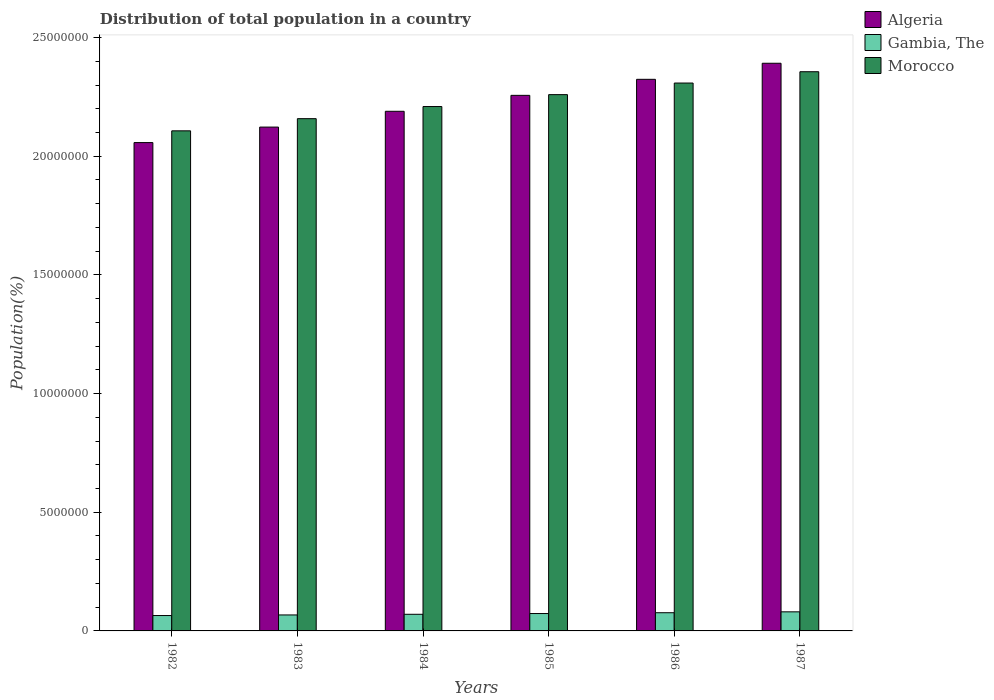How many bars are there on the 1st tick from the right?
Offer a terse response. 3. What is the label of the 6th group of bars from the left?
Your answer should be very brief. 1987. In how many cases, is the number of bars for a given year not equal to the number of legend labels?
Offer a terse response. 0. What is the population of in Gambia, The in 1982?
Keep it short and to the point. 6.48e+05. Across all years, what is the maximum population of in Algeria?
Your answer should be very brief. 2.39e+07. Across all years, what is the minimum population of in Gambia, The?
Keep it short and to the point. 6.48e+05. In which year was the population of in Gambia, The minimum?
Keep it short and to the point. 1982. What is the total population of in Gambia, The in the graph?
Your answer should be very brief. 4.33e+06. What is the difference between the population of in Morocco in 1983 and that in 1987?
Your answer should be very brief. -1.98e+06. What is the difference between the population of in Gambia, The in 1987 and the population of in Morocco in 1983?
Your answer should be very brief. -2.08e+07. What is the average population of in Morocco per year?
Your answer should be very brief. 2.23e+07. In the year 1986, what is the difference between the population of in Gambia, The and population of in Algeria?
Ensure brevity in your answer.  -2.25e+07. In how many years, is the population of in Algeria greater than 18000000 %?
Your response must be concise. 6. What is the ratio of the population of in Morocco in 1982 to that in 1984?
Provide a short and direct response. 0.95. What is the difference between the highest and the second highest population of in Morocco?
Ensure brevity in your answer.  4.76e+05. What is the difference between the highest and the lowest population of in Gambia, The?
Make the answer very short. 1.56e+05. What does the 2nd bar from the left in 1985 represents?
Ensure brevity in your answer.  Gambia, The. What does the 2nd bar from the right in 1985 represents?
Your response must be concise. Gambia, The. Is it the case that in every year, the sum of the population of in Gambia, The and population of in Morocco is greater than the population of in Algeria?
Give a very brief answer. Yes. What is the difference between two consecutive major ticks on the Y-axis?
Provide a short and direct response. 5.00e+06. Are the values on the major ticks of Y-axis written in scientific E-notation?
Make the answer very short. No. Does the graph contain any zero values?
Your answer should be compact. No. How many legend labels are there?
Ensure brevity in your answer.  3. What is the title of the graph?
Ensure brevity in your answer.  Distribution of total population in a country. What is the label or title of the Y-axis?
Ensure brevity in your answer.  Population(%). What is the Population(%) in Algeria in 1982?
Keep it short and to the point. 2.06e+07. What is the Population(%) in Gambia, The in 1982?
Offer a very short reply. 6.48e+05. What is the Population(%) in Morocco in 1982?
Your answer should be compact. 2.11e+07. What is the Population(%) of Algeria in 1983?
Provide a short and direct response. 2.12e+07. What is the Population(%) in Gambia, The in 1983?
Provide a short and direct response. 6.73e+05. What is the Population(%) of Morocco in 1983?
Provide a succinct answer. 2.16e+07. What is the Population(%) in Algeria in 1984?
Offer a very short reply. 2.19e+07. What is the Population(%) in Gambia, The in 1984?
Ensure brevity in your answer.  7.01e+05. What is the Population(%) in Morocco in 1984?
Ensure brevity in your answer.  2.21e+07. What is the Population(%) in Algeria in 1985?
Make the answer very short. 2.26e+07. What is the Population(%) of Gambia, The in 1985?
Give a very brief answer. 7.32e+05. What is the Population(%) of Morocco in 1985?
Provide a succinct answer. 2.26e+07. What is the Population(%) of Algeria in 1986?
Provide a succinct answer. 2.32e+07. What is the Population(%) in Gambia, The in 1986?
Provide a short and direct response. 7.67e+05. What is the Population(%) of Morocco in 1986?
Give a very brief answer. 2.31e+07. What is the Population(%) of Algeria in 1987?
Provide a succinct answer. 2.39e+07. What is the Population(%) in Gambia, The in 1987?
Offer a terse response. 8.04e+05. What is the Population(%) in Morocco in 1987?
Give a very brief answer. 2.36e+07. Across all years, what is the maximum Population(%) of Algeria?
Your answer should be very brief. 2.39e+07. Across all years, what is the maximum Population(%) in Gambia, The?
Provide a short and direct response. 8.04e+05. Across all years, what is the maximum Population(%) in Morocco?
Your answer should be very brief. 2.36e+07. Across all years, what is the minimum Population(%) in Algeria?
Offer a terse response. 2.06e+07. Across all years, what is the minimum Population(%) of Gambia, The?
Make the answer very short. 6.48e+05. Across all years, what is the minimum Population(%) of Morocco?
Offer a very short reply. 2.11e+07. What is the total Population(%) of Algeria in the graph?
Provide a short and direct response. 1.33e+08. What is the total Population(%) in Gambia, The in the graph?
Provide a succinct answer. 4.33e+06. What is the total Population(%) of Morocco in the graph?
Offer a terse response. 1.34e+08. What is the difference between the Population(%) in Algeria in 1982 and that in 1983?
Give a very brief answer. -6.53e+05. What is the difference between the Population(%) in Gambia, The in 1982 and that in 1983?
Make the answer very short. -2.50e+04. What is the difference between the Population(%) of Morocco in 1982 and that in 1983?
Provide a succinct answer. -5.13e+05. What is the difference between the Population(%) in Algeria in 1982 and that in 1984?
Provide a succinct answer. -1.32e+06. What is the difference between the Population(%) in Gambia, The in 1982 and that in 1984?
Provide a short and direct response. -5.29e+04. What is the difference between the Population(%) of Morocco in 1982 and that in 1984?
Offer a very short reply. -1.02e+06. What is the difference between the Population(%) in Algeria in 1982 and that in 1985?
Make the answer very short. -1.99e+06. What is the difference between the Population(%) in Gambia, The in 1982 and that in 1985?
Your answer should be compact. -8.39e+04. What is the difference between the Population(%) in Morocco in 1982 and that in 1985?
Provide a succinct answer. -1.53e+06. What is the difference between the Population(%) of Algeria in 1982 and that in 1986?
Your answer should be very brief. -2.67e+06. What is the difference between the Population(%) in Gambia, The in 1982 and that in 1986?
Provide a short and direct response. -1.18e+05. What is the difference between the Population(%) of Morocco in 1982 and that in 1986?
Offer a terse response. -2.01e+06. What is the difference between the Population(%) of Algeria in 1982 and that in 1987?
Give a very brief answer. -3.34e+06. What is the difference between the Population(%) of Gambia, The in 1982 and that in 1987?
Your response must be concise. -1.56e+05. What is the difference between the Population(%) of Morocco in 1982 and that in 1987?
Your answer should be compact. -2.49e+06. What is the difference between the Population(%) in Algeria in 1983 and that in 1984?
Keep it short and to the point. -6.66e+05. What is the difference between the Population(%) of Gambia, The in 1983 and that in 1984?
Offer a terse response. -2.79e+04. What is the difference between the Population(%) of Morocco in 1983 and that in 1984?
Provide a short and direct response. -5.11e+05. What is the difference between the Population(%) in Algeria in 1983 and that in 1985?
Make the answer very short. -1.34e+06. What is the difference between the Population(%) of Gambia, The in 1983 and that in 1985?
Offer a very short reply. -5.89e+04. What is the difference between the Population(%) of Morocco in 1983 and that in 1985?
Ensure brevity in your answer.  -1.01e+06. What is the difference between the Population(%) in Algeria in 1983 and that in 1986?
Make the answer very short. -2.01e+06. What is the difference between the Population(%) of Gambia, The in 1983 and that in 1986?
Make the answer very short. -9.34e+04. What is the difference between the Population(%) of Morocco in 1983 and that in 1986?
Give a very brief answer. -1.50e+06. What is the difference between the Population(%) in Algeria in 1983 and that in 1987?
Offer a very short reply. -2.69e+06. What is the difference between the Population(%) in Gambia, The in 1983 and that in 1987?
Your answer should be very brief. -1.31e+05. What is the difference between the Population(%) in Morocco in 1983 and that in 1987?
Your response must be concise. -1.98e+06. What is the difference between the Population(%) in Algeria in 1984 and that in 1985?
Your answer should be very brief. -6.72e+05. What is the difference between the Population(%) in Gambia, The in 1984 and that in 1985?
Your answer should be very brief. -3.10e+04. What is the difference between the Population(%) of Morocco in 1984 and that in 1985?
Your answer should be very brief. -5.02e+05. What is the difference between the Population(%) of Algeria in 1984 and that in 1986?
Your response must be concise. -1.35e+06. What is the difference between the Population(%) in Gambia, The in 1984 and that in 1986?
Provide a succinct answer. -6.55e+04. What is the difference between the Population(%) in Morocco in 1984 and that in 1986?
Your answer should be compact. -9.90e+05. What is the difference between the Population(%) in Algeria in 1984 and that in 1987?
Give a very brief answer. -2.02e+06. What is the difference between the Population(%) in Gambia, The in 1984 and that in 1987?
Ensure brevity in your answer.  -1.03e+05. What is the difference between the Population(%) of Morocco in 1984 and that in 1987?
Keep it short and to the point. -1.47e+06. What is the difference between the Population(%) of Algeria in 1985 and that in 1986?
Offer a terse response. -6.75e+05. What is the difference between the Population(%) in Gambia, The in 1985 and that in 1986?
Give a very brief answer. -3.45e+04. What is the difference between the Population(%) of Morocco in 1985 and that in 1986?
Your answer should be very brief. -4.89e+05. What is the difference between the Population(%) of Algeria in 1985 and that in 1987?
Your response must be concise. -1.35e+06. What is the difference between the Population(%) in Gambia, The in 1985 and that in 1987?
Give a very brief answer. -7.20e+04. What is the difference between the Population(%) in Morocco in 1985 and that in 1987?
Give a very brief answer. -9.65e+05. What is the difference between the Population(%) of Algeria in 1986 and that in 1987?
Your response must be concise. -6.77e+05. What is the difference between the Population(%) in Gambia, The in 1986 and that in 1987?
Ensure brevity in your answer.  -3.75e+04. What is the difference between the Population(%) of Morocco in 1986 and that in 1987?
Provide a short and direct response. -4.76e+05. What is the difference between the Population(%) in Algeria in 1982 and the Population(%) in Gambia, The in 1983?
Keep it short and to the point. 1.99e+07. What is the difference between the Population(%) in Algeria in 1982 and the Population(%) in Morocco in 1983?
Keep it short and to the point. -1.01e+06. What is the difference between the Population(%) of Gambia, The in 1982 and the Population(%) of Morocco in 1983?
Offer a terse response. -2.09e+07. What is the difference between the Population(%) of Algeria in 1982 and the Population(%) of Gambia, The in 1984?
Provide a succinct answer. 1.99e+07. What is the difference between the Population(%) in Algeria in 1982 and the Population(%) in Morocco in 1984?
Make the answer very short. -1.52e+06. What is the difference between the Population(%) of Gambia, The in 1982 and the Population(%) of Morocco in 1984?
Offer a very short reply. -2.14e+07. What is the difference between the Population(%) of Algeria in 1982 and the Population(%) of Gambia, The in 1985?
Make the answer very short. 1.98e+07. What is the difference between the Population(%) in Algeria in 1982 and the Population(%) in Morocco in 1985?
Your answer should be compact. -2.02e+06. What is the difference between the Population(%) of Gambia, The in 1982 and the Population(%) of Morocco in 1985?
Offer a terse response. -2.19e+07. What is the difference between the Population(%) in Algeria in 1982 and the Population(%) in Gambia, The in 1986?
Offer a terse response. 1.98e+07. What is the difference between the Population(%) in Algeria in 1982 and the Population(%) in Morocco in 1986?
Make the answer very short. -2.51e+06. What is the difference between the Population(%) in Gambia, The in 1982 and the Population(%) in Morocco in 1986?
Ensure brevity in your answer.  -2.24e+07. What is the difference between the Population(%) in Algeria in 1982 and the Population(%) in Gambia, The in 1987?
Your answer should be very brief. 1.98e+07. What is the difference between the Population(%) in Algeria in 1982 and the Population(%) in Morocco in 1987?
Your response must be concise. -2.99e+06. What is the difference between the Population(%) of Gambia, The in 1982 and the Population(%) of Morocco in 1987?
Make the answer very short. -2.29e+07. What is the difference between the Population(%) of Algeria in 1983 and the Population(%) of Gambia, The in 1984?
Your answer should be very brief. 2.05e+07. What is the difference between the Population(%) in Algeria in 1983 and the Population(%) in Morocco in 1984?
Provide a succinct answer. -8.66e+05. What is the difference between the Population(%) of Gambia, The in 1983 and the Population(%) of Morocco in 1984?
Offer a terse response. -2.14e+07. What is the difference between the Population(%) of Algeria in 1983 and the Population(%) of Gambia, The in 1985?
Offer a very short reply. 2.05e+07. What is the difference between the Population(%) in Algeria in 1983 and the Population(%) in Morocco in 1985?
Provide a short and direct response. -1.37e+06. What is the difference between the Population(%) of Gambia, The in 1983 and the Population(%) of Morocco in 1985?
Offer a terse response. -2.19e+07. What is the difference between the Population(%) of Algeria in 1983 and the Population(%) of Gambia, The in 1986?
Give a very brief answer. 2.05e+07. What is the difference between the Population(%) in Algeria in 1983 and the Population(%) in Morocco in 1986?
Give a very brief answer. -1.86e+06. What is the difference between the Population(%) of Gambia, The in 1983 and the Population(%) of Morocco in 1986?
Provide a succinct answer. -2.24e+07. What is the difference between the Population(%) in Algeria in 1983 and the Population(%) in Gambia, The in 1987?
Your answer should be compact. 2.04e+07. What is the difference between the Population(%) of Algeria in 1983 and the Population(%) of Morocco in 1987?
Provide a short and direct response. -2.33e+06. What is the difference between the Population(%) in Gambia, The in 1983 and the Population(%) in Morocco in 1987?
Offer a very short reply. -2.29e+07. What is the difference between the Population(%) in Algeria in 1984 and the Population(%) in Gambia, The in 1985?
Give a very brief answer. 2.12e+07. What is the difference between the Population(%) of Algeria in 1984 and the Population(%) of Morocco in 1985?
Your answer should be compact. -7.02e+05. What is the difference between the Population(%) of Gambia, The in 1984 and the Population(%) of Morocco in 1985?
Your answer should be compact. -2.19e+07. What is the difference between the Population(%) in Algeria in 1984 and the Population(%) in Gambia, The in 1986?
Make the answer very short. 2.11e+07. What is the difference between the Population(%) in Algeria in 1984 and the Population(%) in Morocco in 1986?
Your answer should be compact. -1.19e+06. What is the difference between the Population(%) of Gambia, The in 1984 and the Population(%) of Morocco in 1986?
Your answer should be compact. -2.24e+07. What is the difference between the Population(%) in Algeria in 1984 and the Population(%) in Gambia, The in 1987?
Give a very brief answer. 2.11e+07. What is the difference between the Population(%) of Algeria in 1984 and the Population(%) of Morocco in 1987?
Your response must be concise. -1.67e+06. What is the difference between the Population(%) of Gambia, The in 1984 and the Population(%) of Morocco in 1987?
Provide a short and direct response. -2.29e+07. What is the difference between the Population(%) of Algeria in 1985 and the Population(%) of Gambia, The in 1986?
Your response must be concise. 2.18e+07. What is the difference between the Population(%) of Algeria in 1985 and the Population(%) of Morocco in 1986?
Provide a short and direct response. -5.19e+05. What is the difference between the Population(%) of Gambia, The in 1985 and the Population(%) of Morocco in 1986?
Provide a succinct answer. -2.24e+07. What is the difference between the Population(%) of Algeria in 1985 and the Population(%) of Gambia, The in 1987?
Make the answer very short. 2.18e+07. What is the difference between the Population(%) in Algeria in 1985 and the Population(%) in Morocco in 1987?
Make the answer very short. -9.95e+05. What is the difference between the Population(%) in Gambia, The in 1985 and the Population(%) in Morocco in 1987?
Offer a terse response. -2.28e+07. What is the difference between the Population(%) of Algeria in 1986 and the Population(%) of Gambia, The in 1987?
Offer a terse response. 2.24e+07. What is the difference between the Population(%) in Algeria in 1986 and the Population(%) in Morocco in 1987?
Make the answer very short. -3.20e+05. What is the difference between the Population(%) of Gambia, The in 1986 and the Population(%) of Morocco in 1987?
Keep it short and to the point. -2.28e+07. What is the average Population(%) in Algeria per year?
Offer a terse response. 2.22e+07. What is the average Population(%) of Gambia, The per year?
Keep it short and to the point. 7.21e+05. What is the average Population(%) of Morocco per year?
Keep it short and to the point. 2.23e+07. In the year 1982, what is the difference between the Population(%) in Algeria and Population(%) in Gambia, The?
Give a very brief answer. 1.99e+07. In the year 1982, what is the difference between the Population(%) of Algeria and Population(%) of Morocco?
Ensure brevity in your answer.  -4.95e+05. In the year 1982, what is the difference between the Population(%) in Gambia, The and Population(%) in Morocco?
Keep it short and to the point. -2.04e+07. In the year 1983, what is the difference between the Population(%) of Algeria and Population(%) of Gambia, The?
Offer a very short reply. 2.06e+07. In the year 1983, what is the difference between the Population(%) in Algeria and Population(%) in Morocco?
Make the answer very short. -3.55e+05. In the year 1983, what is the difference between the Population(%) in Gambia, The and Population(%) in Morocco?
Make the answer very short. -2.09e+07. In the year 1984, what is the difference between the Population(%) in Algeria and Population(%) in Gambia, The?
Ensure brevity in your answer.  2.12e+07. In the year 1984, what is the difference between the Population(%) in Algeria and Population(%) in Morocco?
Provide a short and direct response. -2.01e+05. In the year 1984, what is the difference between the Population(%) in Gambia, The and Population(%) in Morocco?
Keep it short and to the point. -2.14e+07. In the year 1985, what is the difference between the Population(%) in Algeria and Population(%) in Gambia, The?
Offer a very short reply. 2.18e+07. In the year 1985, what is the difference between the Population(%) of Algeria and Population(%) of Morocco?
Give a very brief answer. -3.02e+04. In the year 1985, what is the difference between the Population(%) in Gambia, The and Population(%) in Morocco?
Your answer should be compact. -2.19e+07. In the year 1986, what is the difference between the Population(%) in Algeria and Population(%) in Gambia, The?
Ensure brevity in your answer.  2.25e+07. In the year 1986, what is the difference between the Population(%) in Algeria and Population(%) in Morocco?
Keep it short and to the point. 1.57e+05. In the year 1986, what is the difference between the Population(%) in Gambia, The and Population(%) in Morocco?
Provide a succinct answer. -2.23e+07. In the year 1987, what is the difference between the Population(%) of Algeria and Population(%) of Gambia, The?
Give a very brief answer. 2.31e+07. In the year 1987, what is the difference between the Population(%) of Algeria and Population(%) of Morocco?
Keep it short and to the point. 3.57e+05. In the year 1987, what is the difference between the Population(%) of Gambia, The and Population(%) of Morocco?
Provide a short and direct response. -2.28e+07. What is the ratio of the Population(%) of Algeria in 1982 to that in 1983?
Make the answer very short. 0.97. What is the ratio of the Population(%) of Gambia, The in 1982 to that in 1983?
Offer a terse response. 0.96. What is the ratio of the Population(%) in Morocco in 1982 to that in 1983?
Keep it short and to the point. 0.98. What is the ratio of the Population(%) of Algeria in 1982 to that in 1984?
Your answer should be compact. 0.94. What is the ratio of the Population(%) of Gambia, The in 1982 to that in 1984?
Provide a short and direct response. 0.92. What is the ratio of the Population(%) of Morocco in 1982 to that in 1984?
Offer a very short reply. 0.95. What is the ratio of the Population(%) in Algeria in 1982 to that in 1985?
Your answer should be very brief. 0.91. What is the ratio of the Population(%) of Gambia, The in 1982 to that in 1985?
Your response must be concise. 0.89. What is the ratio of the Population(%) of Morocco in 1982 to that in 1985?
Keep it short and to the point. 0.93. What is the ratio of the Population(%) of Algeria in 1982 to that in 1986?
Your response must be concise. 0.89. What is the ratio of the Population(%) of Gambia, The in 1982 to that in 1986?
Keep it short and to the point. 0.85. What is the ratio of the Population(%) of Morocco in 1982 to that in 1986?
Ensure brevity in your answer.  0.91. What is the ratio of the Population(%) in Algeria in 1982 to that in 1987?
Give a very brief answer. 0.86. What is the ratio of the Population(%) in Gambia, The in 1982 to that in 1987?
Provide a succinct answer. 0.81. What is the ratio of the Population(%) in Morocco in 1982 to that in 1987?
Provide a succinct answer. 0.89. What is the ratio of the Population(%) in Algeria in 1983 to that in 1984?
Your response must be concise. 0.97. What is the ratio of the Population(%) of Gambia, The in 1983 to that in 1984?
Provide a short and direct response. 0.96. What is the ratio of the Population(%) in Morocco in 1983 to that in 1984?
Provide a succinct answer. 0.98. What is the ratio of the Population(%) of Algeria in 1983 to that in 1985?
Offer a very short reply. 0.94. What is the ratio of the Population(%) of Gambia, The in 1983 to that in 1985?
Offer a terse response. 0.92. What is the ratio of the Population(%) in Morocco in 1983 to that in 1985?
Offer a very short reply. 0.96. What is the ratio of the Population(%) in Algeria in 1983 to that in 1986?
Provide a succinct answer. 0.91. What is the ratio of the Population(%) of Gambia, The in 1983 to that in 1986?
Your answer should be very brief. 0.88. What is the ratio of the Population(%) of Morocco in 1983 to that in 1986?
Offer a terse response. 0.94. What is the ratio of the Population(%) in Algeria in 1983 to that in 1987?
Keep it short and to the point. 0.89. What is the ratio of the Population(%) of Gambia, The in 1983 to that in 1987?
Offer a very short reply. 0.84. What is the ratio of the Population(%) in Morocco in 1983 to that in 1987?
Offer a terse response. 0.92. What is the ratio of the Population(%) of Algeria in 1984 to that in 1985?
Keep it short and to the point. 0.97. What is the ratio of the Population(%) in Gambia, The in 1984 to that in 1985?
Your response must be concise. 0.96. What is the ratio of the Population(%) of Morocco in 1984 to that in 1985?
Your response must be concise. 0.98. What is the ratio of the Population(%) of Algeria in 1984 to that in 1986?
Make the answer very short. 0.94. What is the ratio of the Population(%) in Gambia, The in 1984 to that in 1986?
Ensure brevity in your answer.  0.91. What is the ratio of the Population(%) in Morocco in 1984 to that in 1986?
Give a very brief answer. 0.96. What is the ratio of the Population(%) of Algeria in 1984 to that in 1987?
Provide a short and direct response. 0.92. What is the ratio of the Population(%) in Gambia, The in 1984 to that in 1987?
Your answer should be compact. 0.87. What is the ratio of the Population(%) in Morocco in 1984 to that in 1987?
Keep it short and to the point. 0.94. What is the ratio of the Population(%) in Algeria in 1985 to that in 1986?
Keep it short and to the point. 0.97. What is the ratio of the Population(%) of Gambia, The in 1985 to that in 1986?
Provide a succinct answer. 0.95. What is the ratio of the Population(%) of Morocco in 1985 to that in 1986?
Your response must be concise. 0.98. What is the ratio of the Population(%) of Algeria in 1985 to that in 1987?
Keep it short and to the point. 0.94. What is the ratio of the Population(%) in Gambia, The in 1985 to that in 1987?
Offer a terse response. 0.91. What is the ratio of the Population(%) of Morocco in 1985 to that in 1987?
Offer a very short reply. 0.96. What is the ratio of the Population(%) in Algeria in 1986 to that in 1987?
Offer a terse response. 0.97. What is the ratio of the Population(%) in Gambia, The in 1986 to that in 1987?
Make the answer very short. 0.95. What is the ratio of the Population(%) of Morocco in 1986 to that in 1987?
Your answer should be compact. 0.98. What is the difference between the highest and the second highest Population(%) of Algeria?
Your response must be concise. 6.77e+05. What is the difference between the highest and the second highest Population(%) in Gambia, The?
Provide a succinct answer. 3.75e+04. What is the difference between the highest and the second highest Population(%) of Morocco?
Make the answer very short. 4.76e+05. What is the difference between the highest and the lowest Population(%) in Algeria?
Ensure brevity in your answer.  3.34e+06. What is the difference between the highest and the lowest Population(%) in Gambia, The?
Provide a short and direct response. 1.56e+05. What is the difference between the highest and the lowest Population(%) of Morocco?
Offer a very short reply. 2.49e+06. 